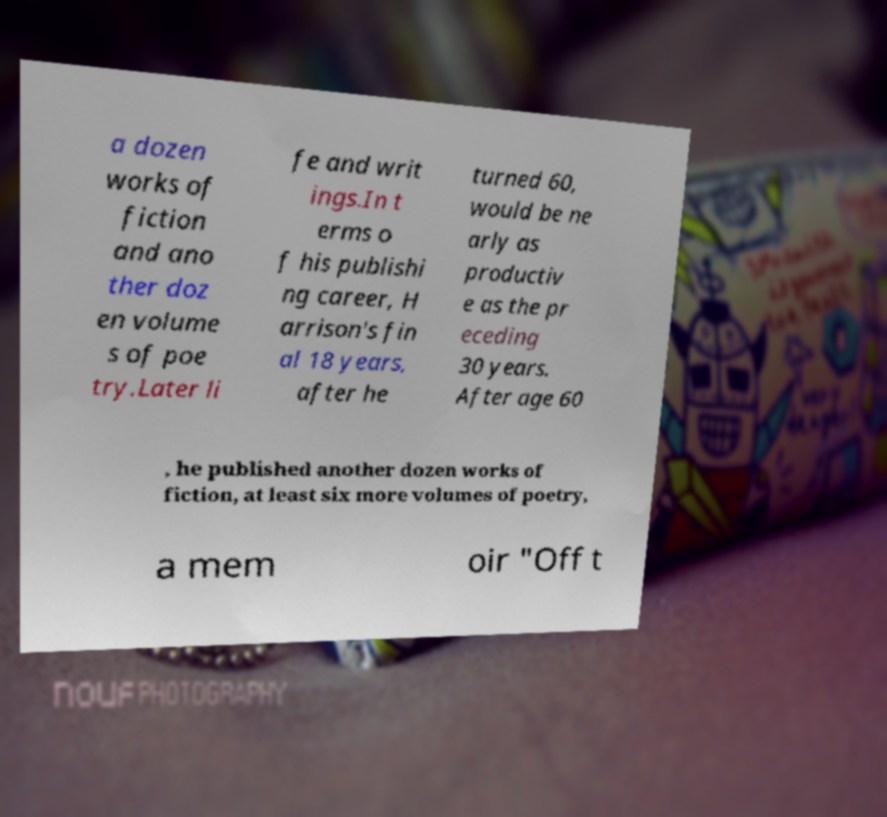Can you read and provide the text displayed in the image?This photo seems to have some interesting text. Can you extract and type it out for me? a dozen works of fiction and ano ther doz en volume s of poe try.Later li fe and writ ings.In t erms o f his publishi ng career, H arrison's fin al 18 years, after he turned 60, would be ne arly as productiv e as the pr eceding 30 years. After age 60 , he published another dozen works of fiction, at least six more volumes of poetry, a mem oir "Off t 